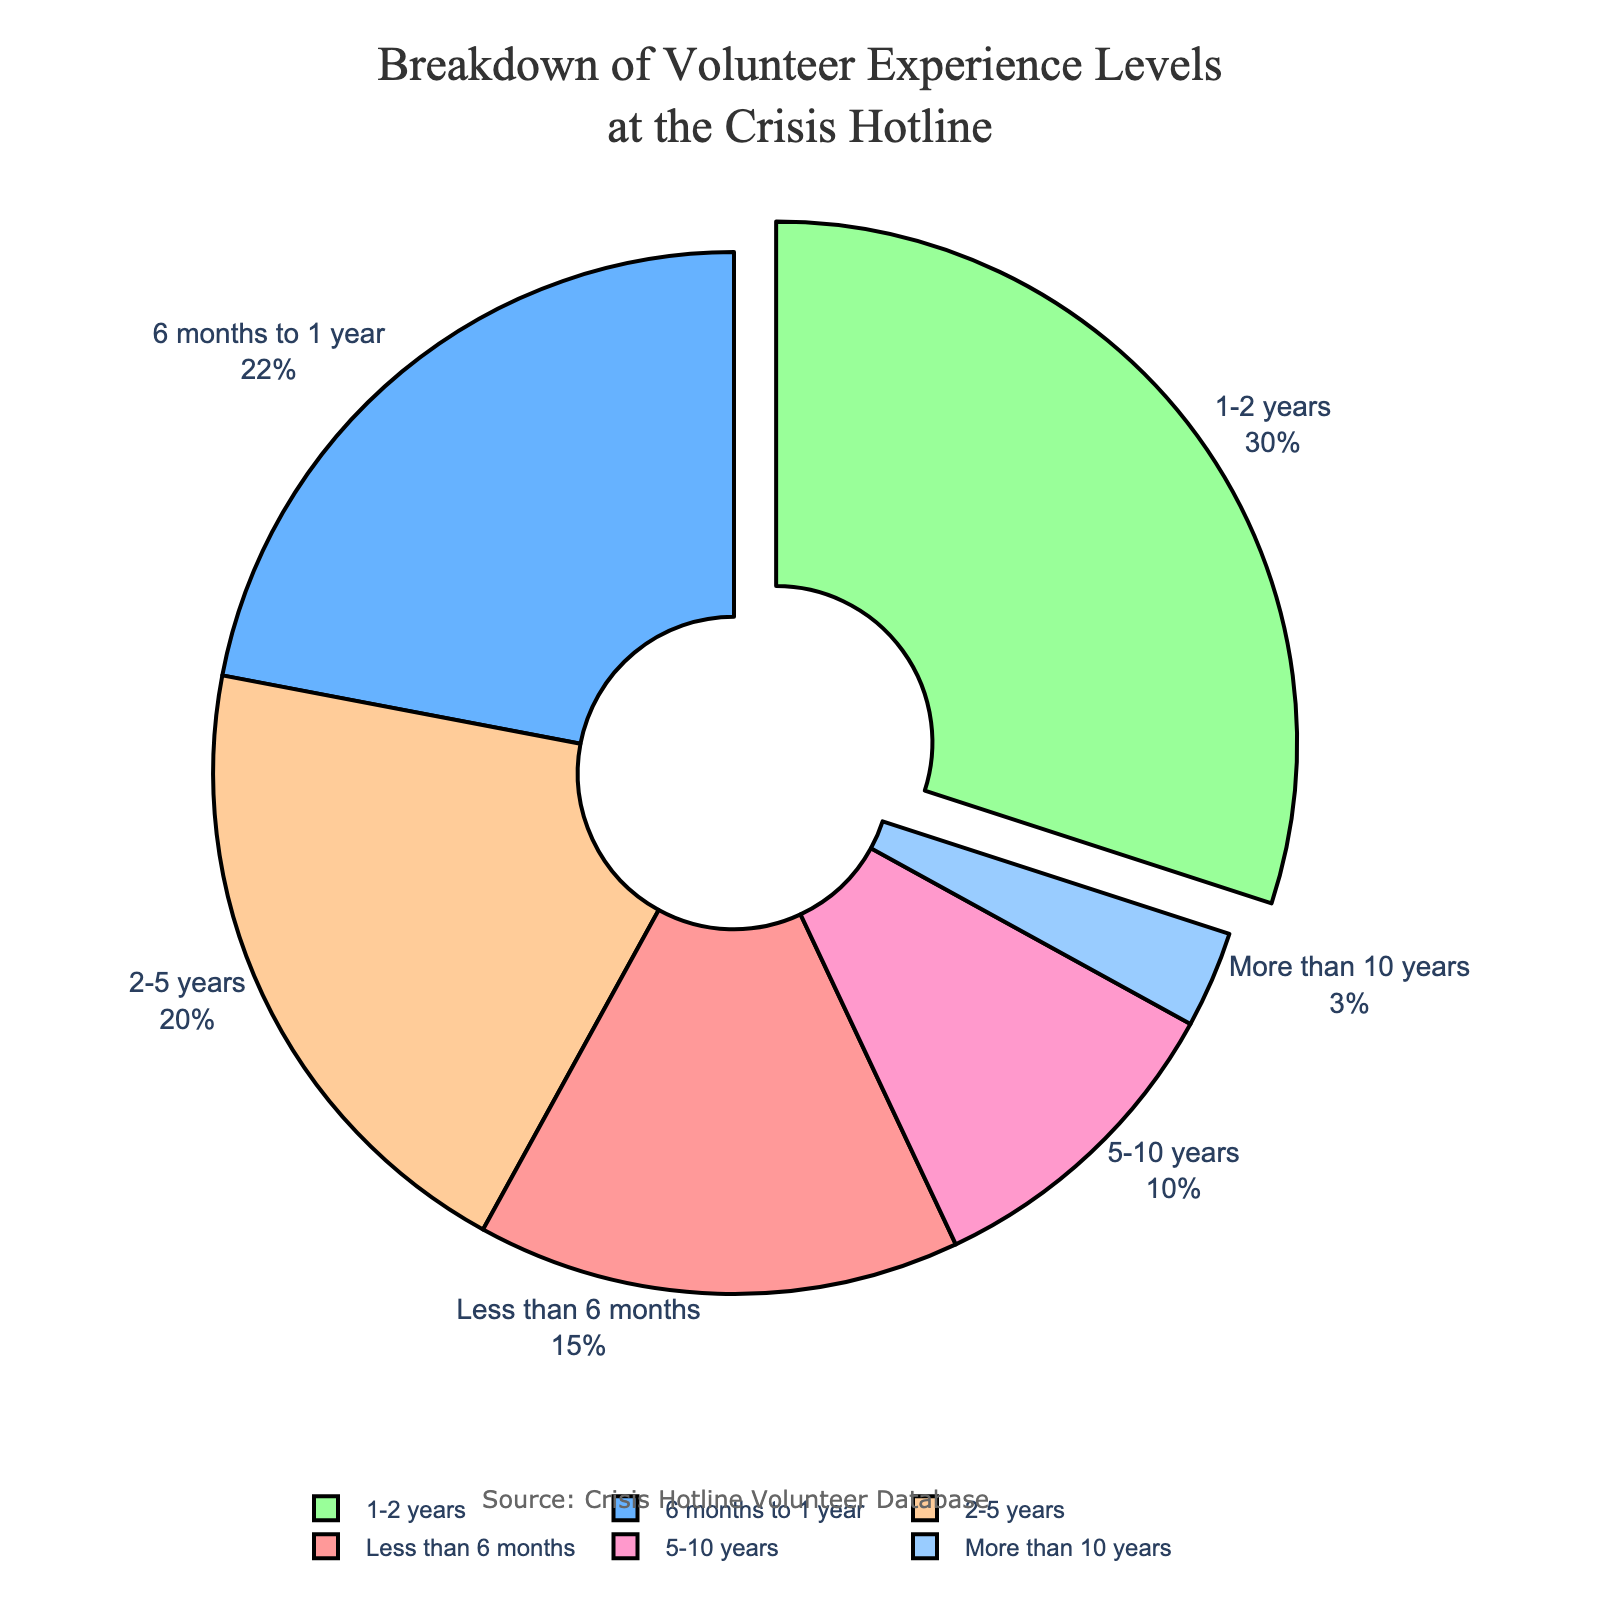What percentage of volunteers have less than a year of experience? Sum the percentages of volunteers with "Less than 6 months" and "6 months to 1 year" experience. 15% + 22% = 37%
Answer: 37% Which experience level has the highest percentage of volunteers? Identify the segment with the largest percentage. The "1-2 years" category has 30%, which is the highest.
Answer: 1-2 years How does the percentage of volunteers with 5-10 years of experience compare to the percentage with 2-5 years of experience? Compare the two percentages: 10% (5-10 years) and 20% (2-5 years). 10% is less than 20%.
Answer: Less What is the total percentage of volunteers with more than 2 years of experience? Sum the percentages of "2-5 years", "5-10 years", and "More than 10 years". 20% + 10% + 3% = 33%
Answer: 33% Which segment is highlighted (pulled out) in the pie chart? The segment corresponding to the maximum percentage is pulled out, which is "1-2 years" with 30%.
Answer: 1-2 years How much larger is the percentage of volunteers with 1-2 years of experience compared to those with more than 10 years of experience? Subtract the smaller percentage from the larger one: 30% (1-2 years) - 3% (More than 10 years) = 27%
Answer: 27% What is the commonly used font and color strategy in the pie chart? The font is from the Arial family, and different segments are colored using distinct colors like red, blue, green, etc. Larger segments are often highlighted by pulling them out.
Answer: Arial, distinct colors What percentage of volunteers have exactly between 6 months and 5 years of experience? Sum the percentages of "6 months to 1 year" and "1-2 years" and "2-5 years": 22% + 30% + 20% = 72%
Answer: 72% How many experience levels have less than 10% of volunteers? Identify the segments with percentages less than 10%. The "More than 10 years" category meets this criterion with 3%.
Answer: 1 